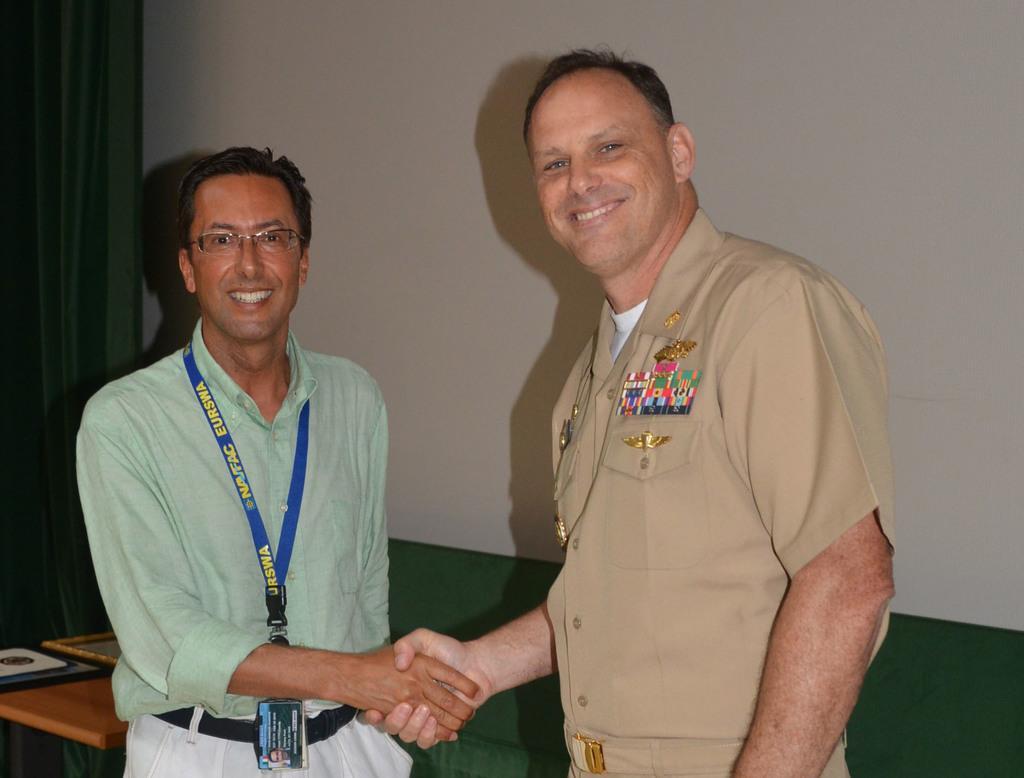How would you summarize this image in a sentence or two? In this image we can see few people. There is a curtain in the image. There is an object at the bottom of the image. A person is wearing an identity card in the image. 